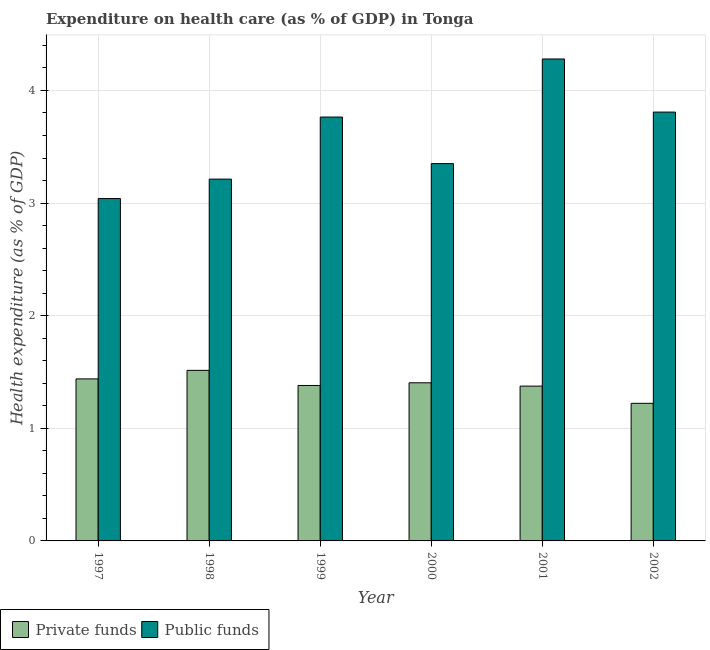How many different coloured bars are there?
Your answer should be compact. 2. How many groups of bars are there?
Make the answer very short. 6. How many bars are there on the 2nd tick from the left?
Offer a terse response. 2. In how many cases, is the number of bars for a given year not equal to the number of legend labels?
Make the answer very short. 0. What is the amount of private funds spent in healthcare in 2002?
Ensure brevity in your answer.  1.22. Across all years, what is the maximum amount of public funds spent in healthcare?
Your response must be concise. 4.28. Across all years, what is the minimum amount of private funds spent in healthcare?
Provide a succinct answer. 1.22. What is the total amount of public funds spent in healthcare in the graph?
Provide a succinct answer. 21.45. What is the difference between the amount of public funds spent in healthcare in 1999 and that in 2002?
Give a very brief answer. -0.04. What is the difference between the amount of private funds spent in healthcare in 2000 and the amount of public funds spent in healthcare in 2001?
Offer a terse response. 0.03. What is the average amount of private funds spent in healthcare per year?
Your answer should be compact. 1.39. In how many years, is the amount of public funds spent in healthcare greater than 1.8 %?
Ensure brevity in your answer.  6. What is the ratio of the amount of public funds spent in healthcare in 1998 to that in 1999?
Offer a terse response. 0.85. Is the amount of private funds spent in healthcare in 1997 less than that in 2000?
Offer a very short reply. No. Is the difference between the amount of public funds spent in healthcare in 1997 and 2000 greater than the difference between the amount of private funds spent in healthcare in 1997 and 2000?
Provide a succinct answer. No. What is the difference between the highest and the second highest amount of private funds spent in healthcare?
Offer a very short reply. 0.08. What is the difference between the highest and the lowest amount of public funds spent in healthcare?
Offer a very short reply. 1.24. In how many years, is the amount of public funds spent in healthcare greater than the average amount of public funds spent in healthcare taken over all years?
Make the answer very short. 3. What does the 2nd bar from the left in 2001 represents?
Make the answer very short. Public funds. What does the 1st bar from the right in 2000 represents?
Offer a terse response. Public funds. How many bars are there?
Your answer should be very brief. 12. Are all the bars in the graph horizontal?
Make the answer very short. No. What is the difference between two consecutive major ticks on the Y-axis?
Provide a short and direct response. 1. Are the values on the major ticks of Y-axis written in scientific E-notation?
Keep it short and to the point. No. Does the graph contain any zero values?
Your answer should be very brief. No. Does the graph contain grids?
Give a very brief answer. Yes. Where does the legend appear in the graph?
Offer a terse response. Bottom left. What is the title of the graph?
Ensure brevity in your answer.  Expenditure on health care (as % of GDP) in Tonga. What is the label or title of the Y-axis?
Make the answer very short. Health expenditure (as % of GDP). What is the Health expenditure (as % of GDP) of Private funds in 1997?
Your response must be concise. 1.44. What is the Health expenditure (as % of GDP) of Public funds in 1997?
Make the answer very short. 3.04. What is the Health expenditure (as % of GDP) in Private funds in 1998?
Keep it short and to the point. 1.51. What is the Health expenditure (as % of GDP) of Public funds in 1998?
Ensure brevity in your answer.  3.21. What is the Health expenditure (as % of GDP) in Private funds in 1999?
Give a very brief answer. 1.38. What is the Health expenditure (as % of GDP) in Public funds in 1999?
Provide a short and direct response. 3.76. What is the Health expenditure (as % of GDP) of Private funds in 2000?
Offer a very short reply. 1.4. What is the Health expenditure (as % of GDP) in Public funds in 2000?
Your response must be concise. 3.35. What is the Health expenditure (as % of GDP) of Private funds in 2001?
Offer a terse response. 1.37. What is the Health expenditure (as % of GDP) of Public funds in 2001?
Ensure brevity in your answer.  4.28. What is the Health expenditure (as % of GDP) of Private funds in 2002?
Make the answer very short. 1.22. What is the Health expenditure (as % of GDP) in Public funds in 2002?
Your answer should be compact. 3.81. Across all years, what is the maximum Health expenditure (as % of GDP) of Private funds?
Make the answer very short. 1.51. Across all years, what is the maximum Health expenditure (as % of GDP) in Public funds?
Your answer should be very brief. 4.28. Across all years, what is the minimum Health expenditure (as % of GDP) of Private funds?
Your response must be concise. 1.22. Across all years, what is the minimum Health expenditure (as % of GDP) of Public funds?
Ensure brevity in your answer.  3.04. What is the total Health expenditure (as % of GDP) of Private funds in the graph?
Ensure brevity in your answer.  8.33. What is the total Health expenditure (as % of GDP) of Public funds in the graph?
Provide a short and direct response. 21.45. What is the difference between the Health expenditure (as % of GDP) of Private funds in 1997 and that in 1998?
Keep it short and to the point. -0.08. What is the difference between the Health expenditure (as % of GDP) in Public funds in 1997 and that in 1998?
Your response must be concise. -0.17. What is the difference between the Health expenditure (as % of GDP) in Private funds in 1997 and that in 1999?
Provide a succinct answer. 0.06. What is the difference between the Health expenditure (as % of GDP) in Public funds in 1997 and that in 1999?
Provide a succinct answer. -0.72. What is the difference between the Health expenditure (as % of GDP) in Private funds in 1997 and that in 2000?
Your answer should be compact. 0.03. What is the difference between the Health expenditure (as % of GDP) of Public funds in 1997 and that in 2000?
Give a very brief answer. -0.31. What is the difference between the Health expenditure (as % of GDP) of Private funds in 1997 and that in 2001?
Ensure brevity in your answer.  0.06. What is the difference between the Health expenditure (as % of GDP) of Public funds in 1997 and that in 2001?
Provide a succinct answer. -1.24. What is the difference between the Health expenditure (as % of GDP) of Private funds in 1997 and that in 2002?
Ensure brevity in your answer.  0.22. What is the difference between the Health expenditure (as % of GDP) of Public funds in 1997 and that in 2002?
Keep it short and to the point. -0.77. What is the difference between the Health expenditure (as % of GDP) in Private funds in 1998 and that in 1999?
Keep it short and to the point. 0.13. What is the difference between the Health expenditure (as % of GDP) of Public funds in 1998 and that in 1999?
Make the answer very short. -0.55. What is the difference between the Health expenditure (as % of GDP) of Private funds in 1998 and that in 2000?
Keep it short and to the point. 0.11. What is the difference between the Health expenditure (as % of GDP) in Public funds in 1998 and that in 2000?
Offer a very short reply. -0.14. What is the difference between the Health expenditure (as % of GDP) of Private funds in 1998 and that in 2001?
Offer a terse response. 0.14. What is the difference between the Health expenditure (as % of GDP) in Public funds in 1998 and that in 2001?
Provide a succinct answer. -1.07. What is the difference between the Health expenditure (as % of GDP) in Private funds in 1998 and that in 2002?
Provide a short and direct response. 0.29. What is the difference between the Health expenditure (as % of GDP) in Public funds in 1998 and that in 2002?
Keep it short and to the point. -0.6. What is the difference between the Health expenditure (as % of GDP) of Private funds in 1999 and that in 2000?
Your answer should be compact. -0.02. What is the difference between the Health expenditure (as % of GDP) in Public funds in 1999 and that in 2000?
Your answer should be compact. 0.41. What is the difference between the Health expenditure (as % of GDP) in Private funds in 1999 and that in 2001?
Offer a terse response. 0.01. What is the difference between the Health expenditure (as % of GDP) of Public funds in 1999 and that in 2001?
Give a very brief answer. -0.52. What is the difference between the Health expenditure (as % of GDP) in Private funds in 1999 and that in 2002?
Keep it short and to the point. 0.16. What is the difference between the Health expenditure (as % of GDP) of Public funds in 1999 and that in 2002?
Offer a terse response. -0.04. What is the difference between the Health expenditure (as % of GDP) of Private funds in 2000 and that in 2001?
Your answer should be very brief. 0.03. What is the difference between the Health expenditure (as % of GDP) of Public funds in 2000 and that in 2001?
Give a very brief answer. -0.93. What is the difference between the Health expenditure (as % of GDP) in Private funds in 2000 and that in 2002?
Offer a terse response. 0.18. What is the difference between the Health expenditure (as % of GDP) in Public funds in 2000 and that in 2002?
Keep it short and to the point. -0.46. What is the difference between the Health expenditure (as % of GDP) of Private funds in 2001 and that in 2002?
Your response must be concise. 0.15. What is the difference between the Health expenditure (as % of GDP) of Public funds in 2001 and that in 2002?
Offer a terse response. 0.47. What is the difference between the Health expenditure (as % of GDP) of Private funds in 1997 and the Health expenditure (as % of GDP) of Public funds in 1998?
Your response must be concise. -1.77. What is the difference between the Health expenditure (as % of GDP) in Private funds in 1997 and the Health expenditure (as % of GDP) in Public funds in 1999?
Offer a terse response. -2.33. What is the difference between the Health expenditure (as % of GDP) in Private funds in 1997 and the Health expenditure (as % of GDP) in Public funds in 2000?
Offer a terse response. -1.91. What is the difference between the Health expenditure (as % of GDP) of Private funds in 1997 and the Health expenditure (as % of GDP) of Public funds in 2001?
Give a very brief answer. -2.84. What is the difference between the Health expenditure (as % of GDP) in Private funds in 1997 and the Health expenditure (as % of GDP) in Public funds in 2002?
Give a very brief answer. -2.37. What is the difference between the Health expenditure (as % of GDP) in Private funds in 1998 and the Health expenditure (as % of GDP) in Public funds in 1999?
Your response must be concise. -2.25. What is the difference between the Health expenditure (as % of GDP) of Private funds in 1998 and the Health expenditure (as % of GDP) of Public funds in 2000?
Offer a terse response. -1.84. What is the difference between the Health expenditure (as % of GDP) of Private funds in 1998 and the Health expenditure (as % of GDP) of Public funds in 2001?
Your answer should be compact. -2.76. What is the difference between the Health expenditure (as % of GDP) of Private funds in 1998 and the Health expenditure (as % of GDP) of Public funds in 2002?
Provide a short and direct response. -2.29. What is the difference between the Health expenditure (as % of GDP) in Private funds in 1999 and the Health expenditure (as % of GDP) in Public funds in 2000?
Your answer should be compact. -1.97. What is the difference between the Health expenditure (as % of GDP) in Private funds in 1999 and the Health expenditure (as % of GDP) in Public funds in 2001?
Provide a short and direct response. -2.9. What is the difference between the Health expenditure (as % of GDP) of Private funds in 1999 and the Health expenditure (as % of GDP) of Public funds in 2002?
Make the answer very short. -2.43. What is the difference between the Health expenditure (as % of GDP) of Private funds in 2000 and the Health expenditure (as % of GDP) of Public funds in 2001?
Give a very brief answer. -2.88. What is the difference between the Health expenditure (as % of GDP) of Private funds in 2000 and the Health expenditure (as % of GDP) of Public funds in 2002?
Offer a terse response. -2.4. What is the difference between the Health expenditure (as % of GDP) of Private funds in 2001 and the Health expenditure (as % of GDP) of Public funds in 2002?
Offer a terse response. -2.43. What is the average Health expenditure (as % of GDP) of Private funds per year?
Offer a terse response. 1.39. What is the average Health expenditure (as % of GDP) in Public funds per year?
Give a very brief answer. 3.58. In the year 1997, what is the difference between the Health expenditure (as % of GDP) in Private funds and Health expenditure (as % of GDP) in Public funds?
Keep it short and to the point. -1.6. In the year 1998, what is the difference between the Health expenditure (as % of GDP) in Private funds and Health expenditure (as % of GDP) in Public funds?
Provide a short and direct response. -1.7. In the year 1999, what is the difference between the Health expenditure (as % of GDP) of Private funds and Health expenditure (as % of GDP) of Public funds?
Keep it short and to the point. -2.38. In the year 2000, what is the difference between the Health expenditure (as % of GDP) of Private funds and Health expenditure (as % of GDP) of Public funds?
Provide a short and direct response. -1.95. In the year 2001, what is the difference between the Health expenditure (as % of GDP) of Private funds and Health expenditure (as % of GDP) of Public funds?
Offer a very short reply. -2.9. In the year 2002, what is the difference between the Health expenditure (as % of GDP) in Private funds and Health expenditure (as % of GDP) in Public funds?
Ensure brevity in your answer.  -2.59. What is the ratio of the Health expenditure (as % of GDP) in Private funds in 1997 to that in 1998?
Give a very brief answer. 0.95. What is the ratio of the Health expenditure (as % of GDP) of Public funds in 1997 to that in 1998?
Ensure brevity in your answer.  0.95. What is the ratio of the Health expenditure (as % of GDP) in Private funds in 1997 to that in 1999?
Give a very brief answer. 1.04. What is the ratio of the Health expenditure (as % of GDP) of Public funds in 1997 to that in 1999?
Offer a very short reply. 0.81. What is the ratio of the Health expenditure (as % of GDP) in Private funds in 1997 to that in 2000?
Your answer should be very brief. 1.02. What is the ratio of the Health expenditure (as % of GDP) of Public funds in 1997 to that in 2000?
Your response must be concise. 0.91. What is the ratio of the Health expenditure (as % of GDP) of Private funds in 1997 to that in 2001?
Keep it short and to the point. 1.05. What is the ratio of the Health expenditure (as % of GDP) of Public funds in 1997 to that in 2001?
Your answer should be compact. 0.71. What is the ratio of the Health expenditure (as % of GDP) of Private funds in 1997 to that in 2002?
Provide a short and direct response. 1.18. What is the ratio of the Health expenditure (as % of GDP) of Public funds in 1997 to that in 2002?
Provide a short and direct response. 0.8. What is the ratio of the Health expenditure (as % of GDP) in Private funds in 1998 to that in 1999?
Your response must be concise. 1.1. What is the ratio of the Health expenditure (as % of GDP) of Public funds in 1998 to that in 1999?
Give a very brief answer. 0.85. What is the ratio of the Health expenditure (as % of GDP) in Private funds in 1998 to that in 2000?
Make the answer very short. 1.08. What is the ratio of the Health expenditure (as % of GDP) in Public funds in 1998 to that in 2000?
Your answer should be very brief. 0.96. What is the ratio of the Health expenditure (as % of GDP) in Private funds in 1998 to that in 2001?
Make the answer very short. 1.1. What is the ratio of the Health expenditure (as % of GDP) of Public funds in 1998 to that in 2001?
Ensure brevity in your answer.  0.75. What is the ratio of the Health expenditure (as % of GDP) in Private funds in 1998 to that in 2002?
Your answer should be compact. 1.24. What is the ratio of the Health expenditure (as % of GDP) of Public funds in 1998 to that in 2002?
Ensure brevity in your answer.  0.84. What is the ratio of the Health expenditure (as % of GDP) in Public funds in 1999 to that in 2000?
Your answer should be very brief. 1.12. What is the ratio of the Health expenditure (as % of GDP) of Private funds in 1999 to that in 2001?
Provide a succinct answer. 1. What is the ratio of the Health expenditure (as % of GDP) of Public funds in 1999 to that in 2001?
Offer a terse response. 0.88. What is the ratio of the Health expenditure (as % of GDP) in Private funds in 1999 to that in 2002?
Keep it short and to the point. 1.13. What is the ratio of the Health expenditure (as % of GDP) of Public funds in 1999 to that in 2002?
Ensure brevity in your answer.  0.99. What is the ratio of the Health expenditure (as % of GDP) of Private funds in 2000 to that in 2001?
Your response must be concise. 1.02. What is the ratio of the Health expenditure (as % of GDP) of Public funds in 2000 to that in 2001?
Keep it short and to the point. 0.78. What is the ratio of the Health expenditure (as % of GDP) of Private funds in 2000 to that in 2002?
Provide a succinct answer. 1.15. What is the ratio of the Health expenditure (as % of GDP) in Public funds in 2000 to that in 2002?
Your answer should be compact. 0.88. What is the ratio of the Health expenditure (as % of GDP) of Private funds in 2001 to that in 2002?
Your response must be concise. 1.13. What is the ratio of the Health expenditure (as % of GDP) of Public funds in 2001 to that in 2002?
Your answer should be compact. 1.12. What is the difference between the highest and the second highest Health expenditure (as % of GDP) in Private funds?
Provide a succinct answer. 0.08. What is the difference between the highest and the second highest Health expenditure (as % of GDP) of Public funds?
Offer a terse response. 0.47. What is the difference between the highest and the lowest Health expenditure (as % of GDP) in Private funds?
Keep it short and to the point. 0.29. What is the difference between the highest and the lowest Health expenditure (as % of GDP) in Public funds?
Provide a succinct answer. 1.24. 